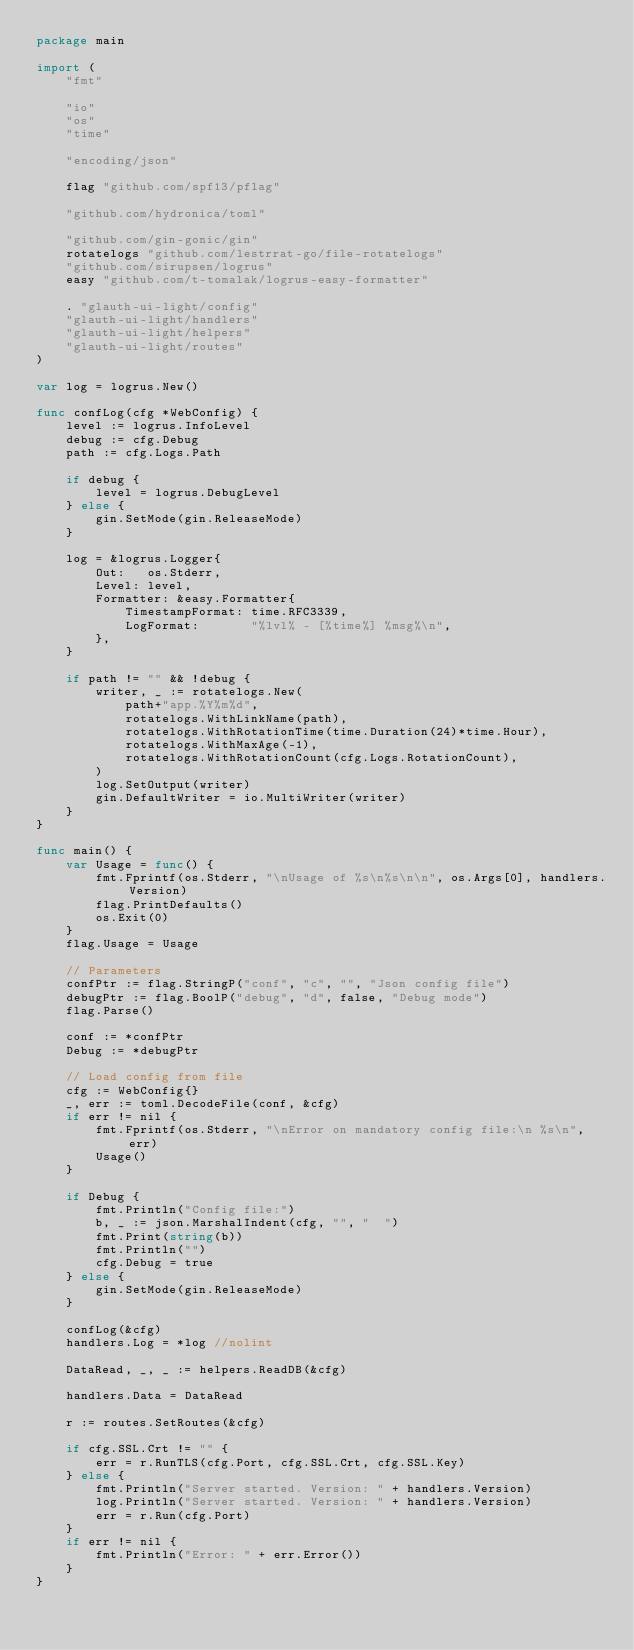<code> <loc_0><loc_0><loc_500><loc_500><_Go_>package main

import (
	"fmt"

	"io"
	"os"
	"time"

	"encoding/json"

	flag "github.com/spf13/pflag"

	"github.com/hydronica/toml"

	"github.com/gin-gonic/gin"
	rotatelogs "github.com/lestrrat-go/file-rotatelogs"
	"github.com/sirupsen/logrus"
	easy "github.com/t-tomalak/logrus-easy-formatter"

	. "glauth-ui-light/config"
	"glauth-ui-light/handlers"
	"glauth-ui-light/helpers"
	"glauth-ui-light/routes"
)

var log = logrus.New()

func confLog(cfg *WebConfig) {
	level := logrus.InfoLevel
	debug := cfg.Debug
	path := cfg.Logs.Path

	if debug {
		level = logrus.DebugLevel
	} else {
		gin.SetMode(gin.ReleaseMode)
	}

	log = &logrus.Logger{
		Out:   os.Stderr,
		Level: level,
		Formatter: &easy.Formatter{
			TimestampFormat: time.RFC3339,
			LogFormat:       "%lvl% - [%time%] %msg%\n",
		},
	}

	if path != "" && !debug {
		writer, _ := rotatelogs.New(
			path+"app.%Y%m%d",
			rotatelogs.WithLinkName(path),
			rotatelogs.WithRotationTime(time.Duration(24)*time.Hour),
			rotatelogs.WithMaxAge(-1),
			rotatelogs.WithRotationCount(cfg.Logs.RotationCount),
		)
		log.SetOutput(writer)
		gin.DefaultWriter = io.MultiWriter(writer)
	}
}

func main() {
	var Usage = func() {
		fmt.Fprintf(os.Stderr, "\nUsage of %s\n%s\n\n", os.Args[0], handlers.Version)
		flag.PrintDefaults()
		os.Exit(0)
	}
	flag.Usage = Usage

	// Parameters
	confPtr := flag.StringP("conf", "c", "", "Json config file")
	debugPtr := flag.BoolP("debug", "d", false, "Debug mode")
	flag.Parse()

	conf := *confPtr
	Debug := *debugPtr

	// Load config from file
	cfg := WebConfig{}
	_, err := toml.DecodeFile(conf, &cfg)
	if err != nil {
		fmt.Fprintf(os.Stderr, "\nError on mandatory config file:\n %s\n", err)
		Usage()
	}

	if Debug {
		fmt.Println("Config file:")
		b, _ := json.MarshalIndent(cfg, "", "  ")
		fmt.Print(string(b))
		fmt.Println("")
		cfg.Debug = true
	} else {
		gin.SetMode(gin.ReleaseMode)
	}

	confLog(&cfg)
	handlers.Log = *log //nolint

	DataRead, _, _ := helpers.ReadDB(&cfg)

	handlers.Data = DataRead

	r := routes.SetRoutes(&cfg)

	if cfg.SSL.Crt != "" {
		err = r.RunTLS(cfg.Port, cfg.SSL.Crt, cfg.SSL.Key)
	} else {
		fmt.Println("Server started. Version: " + handlers.Version)
		log.Println("Server started. Version: " + handlers.Version)
		err = r.Run(cfg.Port)
	}
	if err != nil {
		fmt.Println("Error: " + err.Error())
	}
}
</code> 